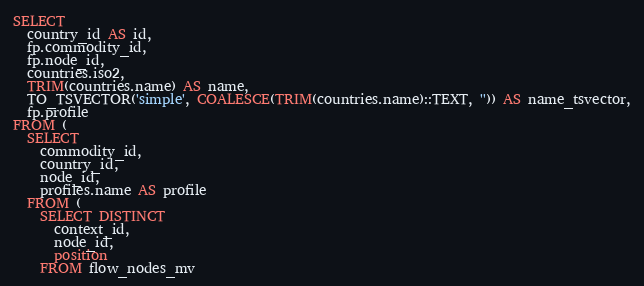Convert code to text. <code><loc_0><loc_0><loc_500><loc_500><_SQL_>SELECT
  country_id AS id,
  fp.commodity_id,
  fp.node_id,
  countries.iso2,
  TRIM(countries.name) AS name,
  TO_TSVECTOR('simple', COALESCE(TRIM(countries.name)::TEXT, '')) AS name_tsvector,
  fp.profile
FROM (
  SELECT
    commodity_id,
    country_id,
    node_id,
    profiles.name AS profile
  FROM (
    SELECT DISTINCT
      context_id,
      node_id,
      position
    FROM flow_nodes_mv</code> 